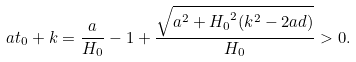Convert formula to latex. <formula><loc_0><loc_0><loc_500><loc_500>a t _ { 0 } + k = \frac { a } { H _ { 0 } } - 1 + \frac { \sqrt { a ^ { 2 } + { H _ { 0 } } ^ { 2 } ( k ^ { 2 } - 2 a d ) } } { H _ { 0 } } > 0 .</formula> 